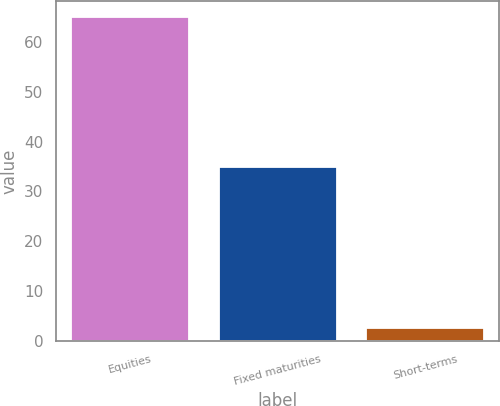<chart> <loc_0><loc_0><loc_500><loc_500><bar_chart><fcel>Equities<fcel>Fixed maturities<fcel>Short-terms<nl><fcel>65<fcel>35<fcel>2.48<nl></chart> 